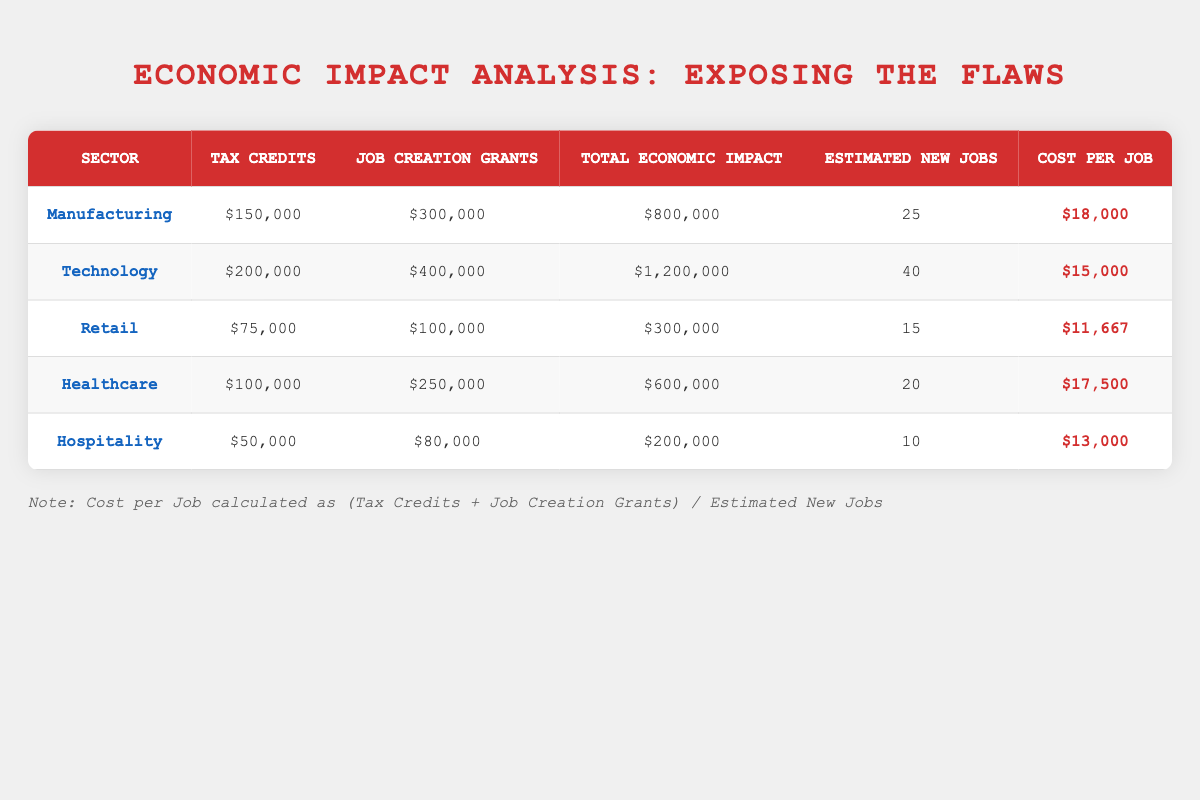What is the total economic impact for the Technology sector? The table shows the economic impact details for various sectors. For the Technology sector, the "Total Economic Impact" is listed as $1,200,000.
Answer: $1,200,000 Which sector received the highest amount in Job Creation Grants? By looking at the "Job Creation Grants" column in the table, we can see that the Technology sector received $400,000, which is the highest compared to other sectors.
Answer: Technology What is the cost per job for the Retail sector? For the Retail sector, the cost per job can be calculated using the formula: (Tax Credits + Job Creation Grants) / Estimated New Jobs. This equals ($75,000 + $100,000) / 15 = $11,667.
Answer: $11,667 Is the total economic impact for the Manufacturing sector greater than that for Hospitality? The total economic impact for the Manufacturing sector is $800,000 while for Hospitality it is $200,000. Since $800,000 is greater than $200,000, the statement is true.
Answer: Yes What is the average estimated new jobs created across all sectors? To find the average, we need to sum the estimated new jobs created for each sector (25 + 40 + 15 + 20 + 10 = 110) and then divide by the number of sectors, which is 5. Thus, the average is 110 / 5 = 22.
Answer: 22 Which sector has the lowest total economic impact? Looking at the "Total Economic Impact" column, we can see that the Hospitality sector has the lowest value, which is $200,000.
Answer: Hospitality What fraction of new jobs created in Technology comes from the total new jobs across all sectors? The total new jobs across all sectors is 110 (25 + 40 + 15 + 20 + 10). The fraction for Technology is the estimated new jobs created (40) divided by the total new jobs (110), resulting in 40/110 or simplified to 4/11.
Answer: 4/11 Is it true that the Healthcare sector has more tax credits than the Retail sector? Comparing the tax credits for the Healthcare sector, which is $100,000, and the Retail sector which is $75,000. Since $100,000 is greater than $75,000, the statement is true.
Answer: Yes 